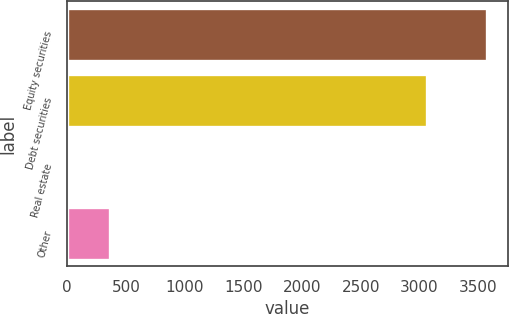Convert chart to OTSL. <chart><loc_0><loc_0><loc_500><loc_500><bar_chart><fcel>Equity securities<fcel>Debt securities<fcel>Real estate<fcel>Other<nl><fcel>3570<fcel>3065<fcel>10<fcel>366<nl></chart> 